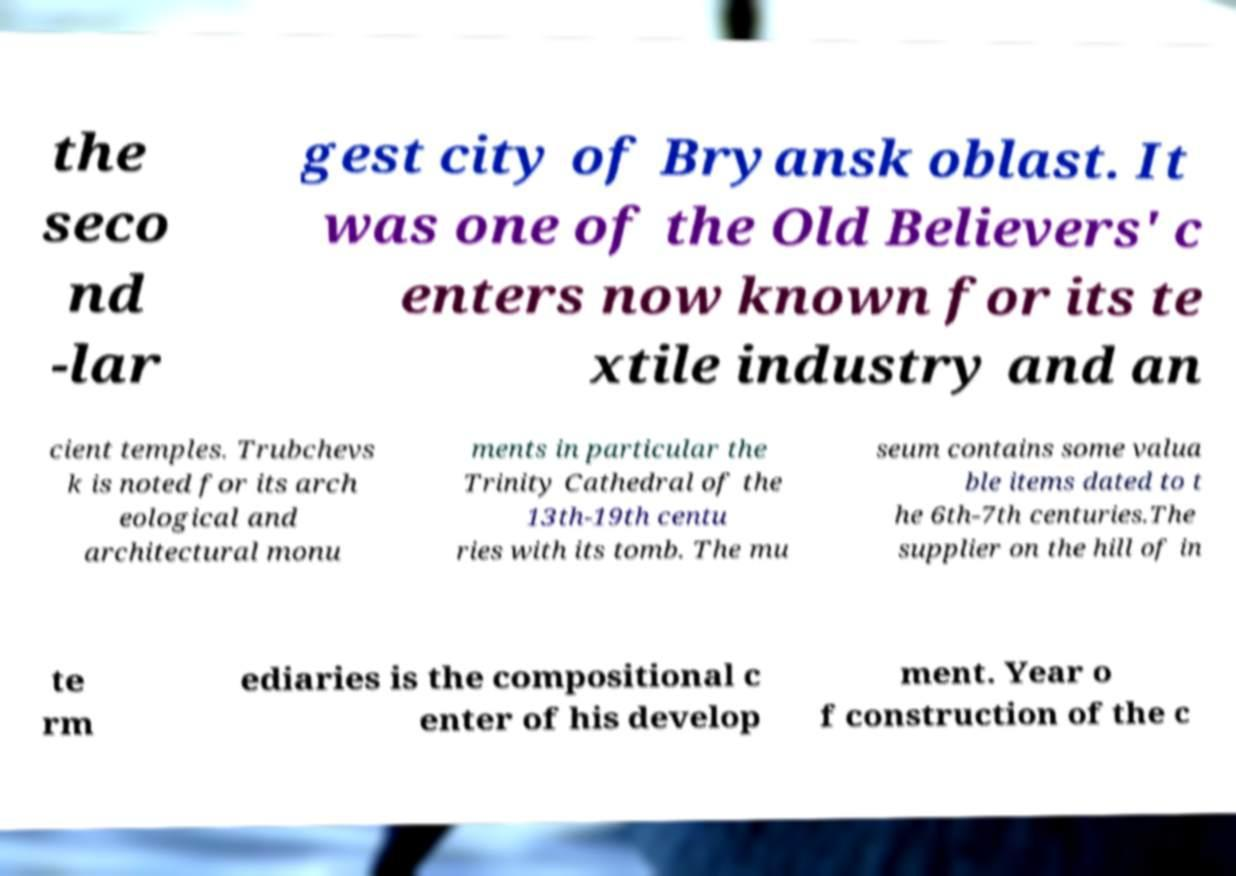What messages or text are displayed in this image? I need them in a readable, typed format. the seco nd -lar gest city of Bryansk oblast. It was one of the Old Believers' c enters now known for its te xtile industry and an cient temples. Trubchevs k is noted for its arch eological and architectural monu ments in particular the Trinity Cathedral of the 13th-19th centu ries with its tomb. The mu seum contains some valua ble items dated to t he 6th-7th centuries.The supplier on the hill of in te rm ediaries is the compositional c enter of his develop ment. Year o f construction of the c 